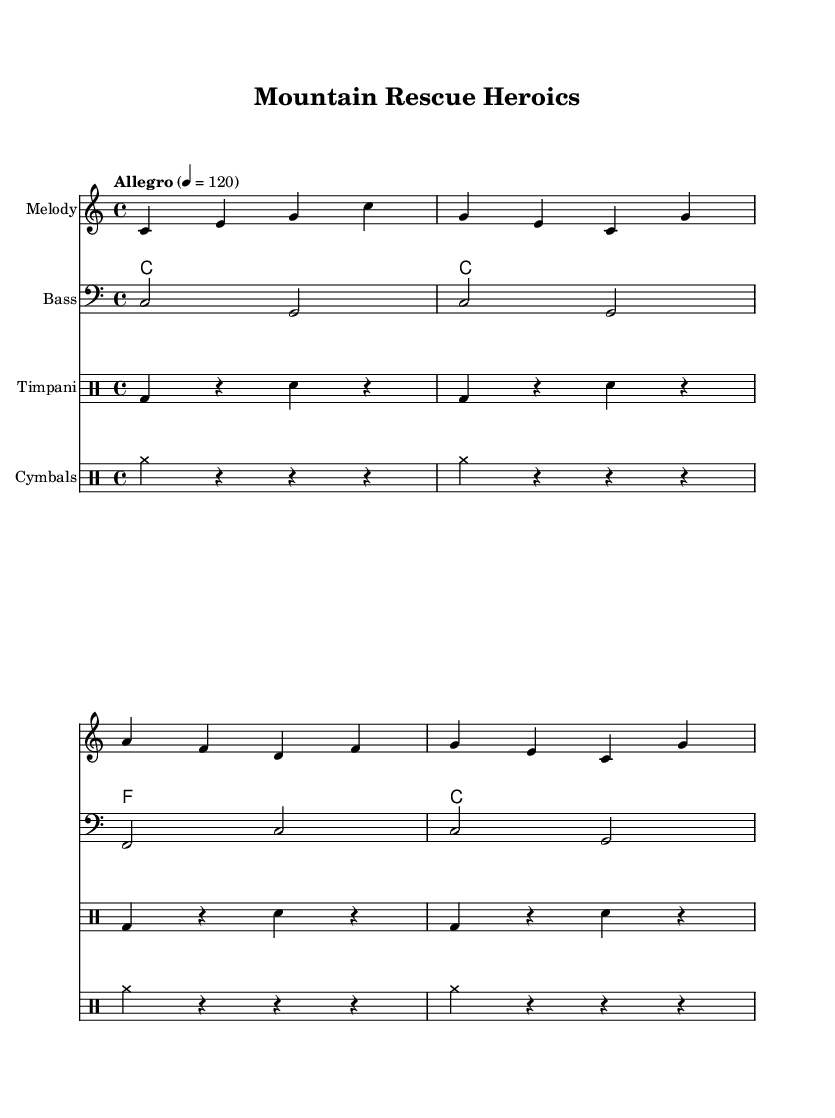What is the key signature of this music? The key signature is C major, which has no sharps or flats.
Answer: C major What is the time signature? The time signature is indicated as 4/4, meaning there are four beats in a measure.
Answer: 4/4 What is the tempo marking? The tempo marking shows "Allegro" with a metronome marking of 120 beats per minute.
Answer: Allegro, 120 How many measures are in the melody? The melody consists of four measures, each separated by vertical lines.
Answer: Four What types of instruments are used in this score? The score includes a melody staff, a bass staff, and two drum staffs for timpani and cymbals.
Answer: Melody, Bass, Timpani, Cymbals What is the rhythmic pattern for the timpani? The timpani rhythm alternates between bass drum hits and snare drum hits in a four-beat pattern.
Answer: Bass and snare alternation What is the harmonic progression in the piece? The harmonic progression follows a pattern of C major, F major, and back to C major across the measures.
Answer: C, F, C 